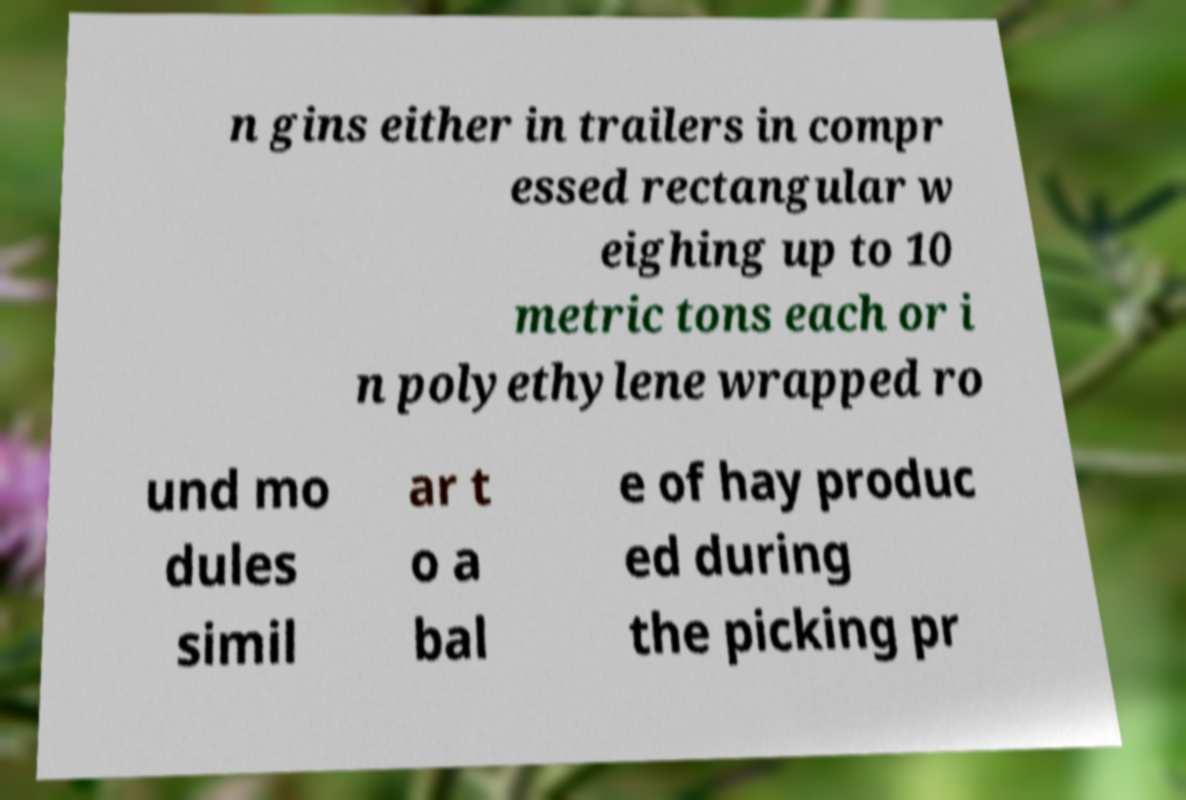Please identify and transcribe the text found in this image. n gins either in trailers in compr essed rectangular w eighing up to 10 metric tons each or i n polyethylene wrapped ro und mo dules simil ar t o a bal e of hay produc ed during the picking pr 